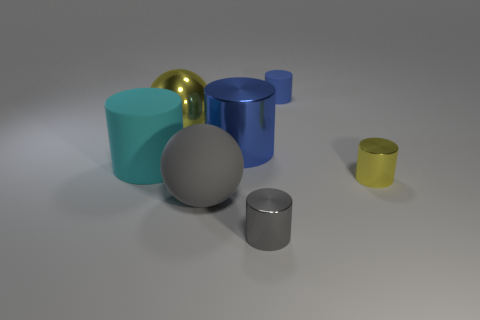Is the size of the rubber cylinder that is in front of the blue rubber cylinder the same as the big blue metallic thing?
Your answer should be compact. Yes. Does the large metallic cylinder have the same color as the tiny matte cylinder?
Your answer should be very brief. Yes. How many small cylinders are both on the right side of the tiny matte object and to the left of the small blue thing?
Keep it short and to the point. 0. What number of rubber cylinders are in front of the yellow object to the right of the metal cylinder that is behind the small yellow metallic cylinder?
Ensure brevity in your answer.  0. What is the size of the metal thing that is the same color as the big shiny ball?
Your answer should be compact. Small. There is a big cyan thing; what shape is it?
Make the answer very short. Cylinder. What number of big yellow balls are made of the same material as the gray cylinder?
Provide a succinct answer. 1. What is the color of the ball that is made of the same material as the tiny gray object?
Your response must be concise. Yellow. There is a cyan matte cylinder; is its size the same as the metallic cylinder in front of the tiny yellow object?
Your answer should be very brief. No. What is the material of the small cylinder behind the thing that is to the left of the yellow shiny thing behind the big cyan object?
Your answer should be very brief. Rubber. 